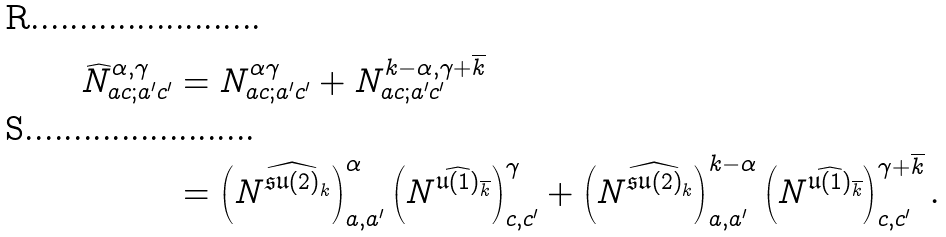<formula> <loc_0><loc_0><loc_500><loc_500>\widehat { N } _ { a c ; a ^ { \prime } c ^ { \prime } } ^ { \alpha , \gamma } & = N _ { a c ; a ^ { \prime } c ^ { \prime } } ^ { \alpha \gamma } + N _ { a c ; a ^ { \prime } c ^ { \prime } } ^ { k - \alpha , \gamma + \overline { k } } \\ & = \left ( N ^ { \widehat { \mathfrak { s u } ( 2 ) } _ { k } } \right ) ^ { \alpha } _ { a , a ^ { \prime } } \left ( N ^ { \widehat { \mathfrak { u } ( 1 ) } _ { \overline { k } } } \right ) ^ { \gamma } _ { c , c ^ { \prime } } + \left ( N ^ { \widehat { \mathfrak { s u } ( 2 ) } _ { k } } \right ) ^ { k - \alpha } _ { a , a ^ { \prime } } \left ( N ^ { \widehat { \mathfrak { u } ( 1 ) } _ { \overline { k } } } \right ) ^ { \gamma + \overline { k } } _ { c , c ^ { \prime } } .</formula> 